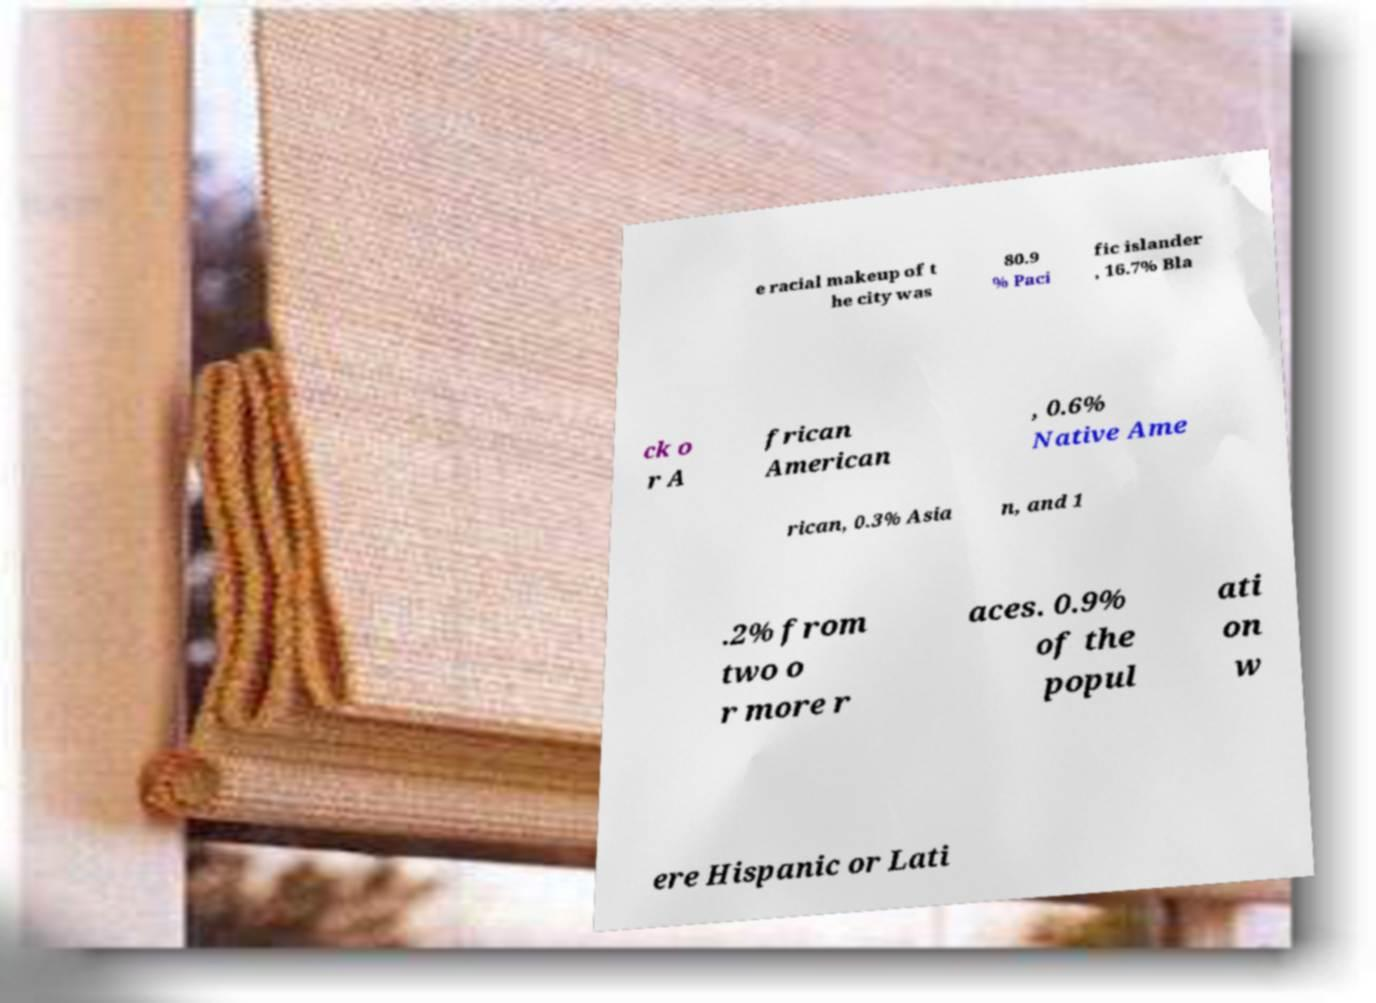What messages or text are displayed in this image? I need them in a readable, typed format. e racial makeup of t he city was 80.9 % Paci fic islander , 16.7% Bla ck o r A frican American , 0.6% Native Ame rican, 0.3% Asia n, and 1 .2% from two o r more r aces. 0.9% of the popul ati on w ere Hispanic or Lati 